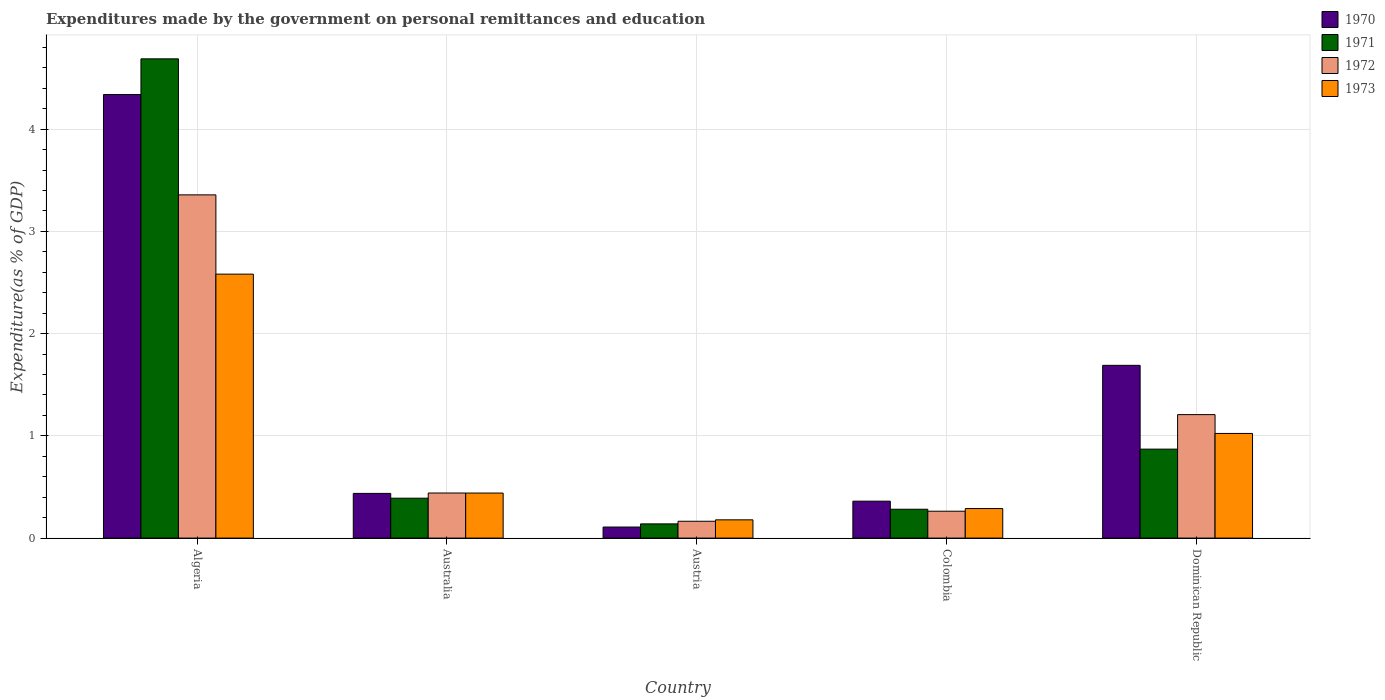How many groups of bars are there?
Provide a succinct answer. 5. Are the number of bars per tick equal to the number of legend labels?
Your response must be concise. Yes. Are the number of bars on each tick of the X-axis equal?
Provide a short and direct response. Yes. How many bars are there on the 3rd tick from the left?
Your answer should be very brief. 4. How many bars are there on the 3rd tick from the right?
Keep it short and to the point. 4. What is the label of the 1st group of bars from the left?
Your answer should be compact. Algeria. What is the expenditures made by the government on personal remittances and education in 1970 in Algeria?
Provide a succinct answer. 4.34. Across all countries, what is the maximum expenditures made by the government on personal remittances and education in 1970?
Offer a terse response. 4.34. Across all countries, what is the minimum expenditures made by the government on personal remittances and education in 1970?
Offer a terse response. 0.11. In which country was the expenditures made by the government on personal remittances and education in 1971 maximum?
Give a very brief answer. Algeria. What is the total expenditures made by the government on personal remittances and education in 1972 in the graph?
Keep it short and to the point. 5.43. What is the difference between the expenditures made by the government on personal remittances and education in 1973 in Algeria and that in Dominican Republic?
Make the answer very short. 1.56. What is the difference between the expenditures made by the government on personal remittances and education in 1970 in Algeria and the expenditures made by the government on personal remittances and education in 1971 in Australia?
Offer a terse response. 3.95. What is the average expenditures made by the government on personal remittances and education in 1971 per country?
Your response must be concise. 1.27. What is the difference between the expenditures made by the government on personal remittances and education of/in 1970 and expenditures made by the government on personal remittances and education of/in 1971 in Austria?
Provide a succinct answer. -0.03. What is the ratio of the expenditures made by the government on personal remittances and education in 1970 in Algeria to that in Austria?
Offer a terse response. 40.14. What is the difference between the highest and the second highest expenditures made by the government on personal remittances and education in 1970?
Provide a succinct answer. -1.25. What is the difference between the highest and the lowest expenditures made by the government on personal remittances and education in 1970?
Your response must be concise. 4.23. What does the 1st bar from the left in Australia represents?
Ensure brevity in your answer.  1970. How many bars are there?
Provide a succinct answer. 20. Are the values on the major ticks of Y-axis written in scientific E-notation?
Ensure brevity in your answer.  No. Does the graph contain grids?
Provide a short and direct response. Yes. How many legend labels are there?
Ensure brevity in your answer.  4. What is the title of the graph?
Offer a very short reply. Expenditures made by the government on personal remittances and education. Does "1961" appear as one of the legend labels in the graph?
Your response must be concise. No. What is the label or title of the Y-axis?
Provide a succinct answer. Expenditure(as % of GDP). What is the Expenditure(as % of GDP) in 1970 in Algeria?
Your response must be concise. 4.34. What is the Expenditure(as % of GDP) of 1971 in Algeria?
Offer a terse response. 4.69. What is the Expenditure(as % of GDP) of 1972 in Algeria?
Your answer should be very brief. 3.36. What is the Expenditure(as % of GDP) of 1973 in Algeria?
Your response must be concise. 2.58. What is the Expenditure(as % of GDP) in 1970 in Australia?
Your answer should be compact. 0.44. What is the Expenditure(as % of GDP) of 1971 in Australia?
Make the answer very short. 0.39. What is the Expenditure(as % of GDP) of 1972 in Australia?
Provide a short and direct response. 0.44. What is the Expenditure(as % of GDP) of 1973 in Australia?
Provide a short and direct response. 0.44. What is the Expenditure(as % of GDP) in 1970 in Austria?
Your answer should be compact. 0.11. What is the Expenditure(as % of GDP) of 1971 in Austria?
Your answer should be very brief. 0.14. What is the Expenditure(as % of GDP) of 1972 in Austria?
Offer a terse response. 0.16. What is the Expenditure(as % of GDP) of 1973 in Austria?
Your response must be concise. 0.18. What is the Expenditure(as % of GDP) of 1970 in Colombia?
Your answer should be very brief. 0.36. What is the Expenditure(as % of GDP) in 1971 in Colombia?
Offer a terse response. 0.28. What is the Expenditure(as % of GDP) in 1972 in Colombia?
Offer a very short reply. 0.26. What is the Expenditure(as % of GDP) of 1973 in Colombia?
Make the answer very short. 0.29. What is the Expenditure(as % of GDP) of 1970 in Dominican Republic?
Offer a very short reply. 1.69. What is the Expenditure(as % of GDP) of 1971 in Dominican Republic?
Your response must be concise. 0.87. What is the Expenditure(as % of GDP) in 1972 in Dominican Republic?
Provide a short and direct response. 1.21. What is the Expenditure(as % of GDP) in 1973 in Dominican Republic?
Your answer should be compact. 1.02. Across all countries, what is the maximum Expenditure(as % of GDP) of 1970?
Provide a short and direct response. 4.34. Across all countries, what is the maximum Expenditure(as % of GDP) in 1971?
Your answer should be compact. 4.69. Across all countries, what is the maximum Expenditure(as % of GDP) of 1972?
Your answer should be compact. 3.36. Across all countries, what is the maximum Expenditure(as % of GDP) of 1973?
Provide a succinct answer. 2.58. Across all countries, what is the minimum Expenditure(as % of GDP) of 1970?
Provide a short and direct response. 0.11. Across all countries, what is the minimum Expenditure(as % of GDP) of 1971?
Provide a short and direct response. 0.14. Across all countries, what is the minimum Expenditure(as % of GDP) in 1972?
Provide a succinct answer. 0.16. Across all countries, what is the minimum Expenditure(as % of GDP) in 1973?
Provide a succinct answer. 0.18. What is the total Expenditure(as % of GDP) in 1970 in the graph?
Keep it short and to the point. 6.93. What is the total Expenditure(as % of GDP) in 1971 in the graph?
Provide a succinct answer. 6.37. What is the total Expenditure(as % of GDP) of 1972 in the graph?
Give a very brief answer. 5.43. What is the total Expenditure(as % of GDP) in 1973 in the graph?
Your response must be concise. 4.51. What is the difference between the Expenditure(as % of GDP) of 1970 in Algeria and that in Australia?
Keep it short and to the point. 3.9. What is the difference between the Expenditure(as % of GDP) of 1971 in Algeria and that in Australia?
Ensure brevity in your answer.  4.3. What is the difference between the Expenditure(as % of GDP) in 1972 in Algeria and that in Australia?
Offer a terse response. 2.92. What is the difference between the Expenditure(as % of GDP) in 1973 in Algeria and that in Australia?
Provide a short and direct response. 2.14. What is the difference between the Expenditure(as % of GDP) of 1970 in Algeria and that in Austria?
Your response must be concise. 4.23. What is the difference between the Expenditure(as % of GDP) in 1971 in Algeria and that in Austria?
Provide a short and direct response. 4.55. What is the difference between the Expenditure(as % of GDP) of 1972 in Algeria and that in Austria?
Give a very brief answer. 3.19. What is the difference between the Expenditure(as % of GDP) in 1973 in Algeria and that in Austria?
Keep it short and to the point. 2.4. What is the difference between the Expenditure(as % of GDP) in 1970 in Algeria and that in Colombia?
Make the answer very short. 3.98. What is the difference between the Expenditure(as % of GDP) in 1971 in Algeria and that in Colombia?
Provide a succinct answer. 4.41. What is the difference between the Expenditure(as % of GDP) of 1972 in Algeria and that in Colombia?
Give a very brief answer. 3.09. What is the difference between the Expenditure(as % of GDP) in 1973 in Algeria and that in Colombia?
Keep it short and to the point. 2.29. What is the difference between the Expenditure(as % of GDP) of 1970 in Algeria and that in Dominican Republic?
Keep it short and to the point. 2.65. What is the difference between the Expenditure(as % of GDP) in 1971 in Algeria and that in Dominican Republic?
Offer a very short reply. 3.82. What is the difference between the Expenditure(as % of GDP) in 1972 in Algeria and that in Dominican Republic?
Your response must be concise. 2.15. What is the difference between the Expenditure(as % of GDP) in 1973 in Algeria and that in Dominican Republic?
Offer a terse response. 1.56. What is the difference between the Expenditure(as % of GDP) of 1970 in Australia and that in Austria?
Keep it short and to the point. 0.33. What is the difference between the Expenditure(as % of GDP) in 1971 in Australia and that in Austria?
Ensure brevity in your answer.  0.25. What is the difference between the Expenditure(as % of GDP) of 1972 in Australia and that in Austria?
Your answer should be very brief. 0.28. What is the difference between the Expenditure(as % of GDP) of 1973 in Australia and that in Austria?
Your answer should be compact. 0.26. What is the difference between the Expenditure(as % of GDP) in 1970 in Australia and that in Colombia?
Provide a short and direct response. 0.08. What is the difference between the Expenditure(as % of GDP) in 1971 in Australia and that in Colombia?
Ensure brevity in your answer.  0.11. What is the difference between the Expenditure(as % of GDP) in 1972 in Australia and that in Colombia?
Offer a very short reply. 0.18. What is the difference between the Expenditure(as % of GDP) of 1973 in Australia and that in Colombia?
Make the answer very short. 0.15. What is the difference between the Expenditure(as % of GDP) in 1970 in Australia and that in Dominican Republic?
Keep it short and to the point. -1.25. What is the difference between the Expenditure(as % of GDP) in 1971 in Australia and that in Dominican Republic?
Make the answer very short. -0.48. What is the difference between the Expenditure(as % of GDP) of 1972 in Australia and that in Dominican Republic?
Your answer should be compact. -0.77. What is the difference between the Expenditure(as % of GDP) in 1973 in Australia and that in Dominican Republic?
Provide a succinct answer. -0.58. What is the difference between the Expenditure(as % of GDP) of 1970 in Austria and that in Colombia?
Your response must be concise. -0.25. What is the difference between the Expenditure(as % of GDP) in 1971 in Austria and that in Colombia?
Your answer should be very brief. -0.14. What is the difference between the Expenditure(as % of GDP) in 1972 in Austria and that in Colombia?
Give a very brief answer. -0.1. What is the difference between the Expenditure(as % of GDP) of 1973 in Austria and that in Colombia?
Give a very brief answer. -0.11. What is the difference between the Expenditure(as % of GDP) of 1970 in Austria and that in Dominican Republic?
Keep it short and to the point. -1.58. What is the difference between the Expenditure(as % of GDP) of 1971 in Austria and that in Dominican Republic?
Provide a short and direct response. -0.73. What is the difference between the Expenditure(as % of GDP) of 1972 in Austria and that in Dominican Republic?
Your answer should be compact. -1.04. What is the difference between the Expenditure(as % of GDP) in 1973 in Austria and that in Dominican Republic?
Offer a very short reply. -0.84. What is the difference between the Expenditure(as % of GDP) in 1970 in Colombia and that in Dominican Republic?
Provide a succinct answer. -1.33. What is the difference between the Expenditure(as % of GDP) of 1971 in Colombia and that in Dominican Republic?
Give a very brief answer. -0.59. What is the difference between the Expenditure(as % of GDP) in 1972 in Colombia and that in Dominican Republic?
Provide a succinct answer. -0.94. What is the difference between the Expenditure(as % of GDP) in 1973 in Colombia and that in Dominican Republic?
Make the answer very short. -0.73. What is the difference between the Expenditure(as % of GDP) of 1970 in Algeria and the Expenditure(as % of GDP) of 1971 in Australia?
Keep it short and to the point. 3.95. What is the difference between the Expenditure(as % of GDP) of 1970 in Algeria and the Expenditure(as % of GDP) of 1972 in Australia?
Keep it short and to the point. 3.9. What is the difference between the Expenditure(as % of GDP) in 1970 in Algeria and the Expenditure(as % of GDP) in 1973 in Australia?
Provide a succinct answer. 3.9. What is the difference between the Expenditure(as % of GDP) of 1971 in Algeria and the Expenditure(as % of GDP) of 1972 in Australia?
Provide a short and direct response. 4.25. What is the difference between the Expenditure(as % of GDP) in 1971 in Algeria and the Expenditure(as % of GDP) in 1973 in Australia?
Offer a very short reply. 4.25. What is the difference between the Expenditure(as % of GDP) of 1972 in Algeria and the Expenditure(as % of GDP) of 1973 in Australia?
Your response must be concise. 2.92. What is the difference between the Expenditure(as % of GDP) of 1970 in Algeria and the Expenditure(as % of GDP) of 1971 in Austria?
Ensure brevity in your answer.  4.2. What is the difference between the Expenditure(as % of GDP) of 1970 in Algeria and the Expenditure(as % of GDP) of 1972 in Austria?
Offer a terse response. 4.17. What is the difference between the Expenditure(as % of GDP) in 1970 in Algeria and the Expenditure(as % of GDP) in 1973 in Austria?
Provide a succinct answer. 4.16. What is the difference between the Expenditure(as % of GDP) in 1971 in Algeria and the Expenditure(as % of GDP) in 1972 in Austria?
Provide a succinct answer. 4.52. What is the difference between the Expenditure(as % of GDP) of 1971 in Algeria and the Expenditure(as % of GDP) of 1973 in Austria?
Keep it short and to the point. 4.51. What is the difference between the Expenditure(as % of GDP) of 1972 in Algeria and the Expenditure(as % of GDP) of 1973 in Austria?
Offer a terse response. 3.18. What is the difference between the Expenditure(as % of GDP) in 1970 in Algeria and the Expenditure(as % of GDP) in 1971 in Colombia?
Provide a short and direct response. 4.06. What is the difference between the Expenditure(as % of GDP) of 1970 in Algeria and the Expenditure(as % of GDP) of 1972 in Colombia?
Offer a very short reply. 4.08. What is the difference between the Expenditure(as % of GDP) of 1970 in Algeria and the Expenditure(as % of GDP) of 1973 in Colombia?
Make the answer very short. 4.05. What is the difference between the Expenditure(as % of GDP) in 1971 in Algeria and the Expenditure(as % of GDP) in 1972 in Colombia?
Provide a short and direct response. 4.42. What is the difference between the Expenditure(as % of GDP) of 1971 in Algeria and the Expenditure(as % of GDP) of 1973 in Colombia?
Keep it short and to the point. 4.4. What is the difference between the Expenditure(as % of GDP) in 1972 in Algeria and the Expenditure(as % of GDP) in 1973 in Colombia?
Make the answer very short. 3.07. What is the difference between the Expenditure(as % of GDP) in 1970 in Algeria and the Expenditure(as % of GDP) in 1971 in Dominican Republic?
Your answer should be compact. 3.47. What is the difference between the Expenditure(as % of GDP) of 1970 in Algeria and the Expenditure(as % of GDP) of 1972 in Dominican Republic?
Provide a short and direct response. 3.13. What is the difference between the Expenditure(as % of GDP) of 1970 in Algeria and the Expenditure(as % of GDP) of 1973 in Dominican Republic?
Offer a very short reply. 3.31. What is the difference between the Expenditure(as % of GDP) in 1971 in Algeria and the Expenditure(as % of GDP) in 1972 in Dominican Republic?
Your answer should be very brief. 3.48. What is the difference between the Expenditure(as % of GDP) of 1971 in Algeria and the Expenditure(as % of GDP) of 1973 in Dominican Republic?
Your answer should be compact. 3.66. What is the difference between the Expenditure(as % of GDP) in 1972 in Algeria and the Expenditure(as % of GDP) in 1973 in Dominican Republic?
Give a very brief answer. 2.33. What is the difference between the Expenditure(as % of GDP) in 1970 in Australia and the Expenditure(as % of GDP) in 1971 in Austria?
Give a very brief answer. 0.3. What is the difference between the Expenditure(as % of GDP) of 1970 in Australia and the Expenditure(as % of GDP) of 1972 in Austria?
Offer a very short reply. 0.27. What is the difference between the Expenditure(as % of GDP) in 1970 in Australia and the Expenditure(as % of GDP) in 1973 in Austria?
Your answer should be compact. 0.26. What is the difference between the Expenditure(as % of GDP) in 1971 in Australia and the Expenditure(as % of GDP) in 1972 in Austria?
Make the answer very short. 0.23. What is the difference between the Expenditure(as % of GDP) in 1971 in Australia and the Expenditure(as % of GDP) in 1973 in Austria?
Give a very brief answer. 0.21. What is the difference between the Expenditure(as % of GDP) of 1972 in Australia and the Expenditure(as % of GDP) of 1973 in Austria?
Provide a succinct answer. 0.26. What is the difference between the Expenditure(as % of GDP) of 1970 in Australia and the Expenditure(as % of GDP) of 1971 in Colombia?
Make the answer very short. 0.15. What is the difference between the Expenditure(as % of GDP) in 1970 in Australia and the Expenditure(as % of GDP) in 1972 in Colombia?
Provide a succinct answer. 0.17. What is the difference between the Expenditure(as % of GDP) of 1970 in Australia and the Expenditure(as % of GDP) of 1973 in Colombia?
Provide a succinct answer. 0.15. What is the difference between the Expenditure(as % of GDP) of 1971 in Australia and the Expenditure(as % of GDP) of 1972 in Colombia?
Make the answer very short. 0.13. What is the difference between the Expenditure(as % of GDP) of 1971 in Australia and the Expenditure(as % of GDP) of 1973 in Colombia?
Your answer should be very brief. 0.1. What is the difference between the Expenditure(as % of GDP) of 1972 in Australia and the Expenditure(as % of GDP) of 1973 in Colombia?
Offer a terse response. 0.15. What is the difference between the Expenditure(as % of GDP) of 1970 in Australia and the Expenditure(as % of GDP) of 1971 in Dominican Republic?
Make the answer very short. -0.43. What is the difference between the Expenditure(as % of GDP) in 1970 in Australia and the Expenditure(as % of GDP) in 1972 in Dominican Republic?
Your answer should be very brief. -0.77. What is the difference between the Expenditure(as % of GDP) of 1970 in Australia and the Expenditure(as % of GDP) of 1973 in Dominican Republic?
Offer a terse response. -0.59. What is the difference between the Expenditure(as % of GDP) in 1971 in Australia and the Expenditure(as % of GDP) in 1972 in Dominican Republic?
Provide a succinct answer. -0.82. What is the difference between the Expenditure(as % of GDP) in 1971 in Australia and the Expenditure(as % of GDP) in 1973 in Dominican Republic?
Keep it short and to the point. -0.63. What is the difference between the Expenditure(as % of GDP) of 1972 in Australia and the Expenditure(as % of GDP) of 1973 in Dominican Republic?
Offer a very short reply. -0.58. What is the difference between the Expenditure(as % of GDP) in 1970 in Austria and the Expenditure(as % of GDP) in 1971 in Colombia?
Give a very brief answer. -0.17. What is the difference between the Expenditure(as % of GDP) in 1970 in Austria and the Expenditure(as % of GDP) in 1972 in Colombia?
Your answer should be very brief. -0.15. What is the difference between the Expenditure(as % of GDP) in 1970 in Austria and the Expenditure(as % of GDP) in 1973 in Colombia?
Your response must be concise. -0.18. What is the difference between the Expenditure(as % of GDP) of 1971 in Austria and the Expenditure(as % of GDP) of 1972 in Colombia?
Offer a terse response. -0.12. What is the difference between the Expenditure(as % of GDP) of 1971 in Austria and the Expenditure(as % of GDP) of 1973 in Colombia?
Offer a very short reply. -0.15. What is the difference between the Expenditure(as % of GDP) of 1972 in Austria and the Expenditure(as % of GDP) of 1973 in Colombia?
Provide a succinct answer. -0.12. What is the difference between the Expenditure(as % of GDP) of 1970 in Austria and the Expenditure(as % of GDP) of 1971 in Dominican Republic?
Give a very brief answer. -0.76. What is the difference between the Expenditure(as % of GDP) of 1970 in Austria and the Expenditure(as % of GDP) of 1972 in Dominican Republic?
Ensure brevity in your answer.  -1.1. What is the difference between the Expenditure(as % of GDP) in 1970 in Austria and the Expenditure(as % of GDP) in 1973 in Dominican Republic?
Offer a very short reply. -0.92. What is the difference between the Expenditure(as % of GDP) of 1971 in Austria and the Expenditure(as % of GDP) of 1972 in Dominican Republic?
Give a very brief answer. -1.07. What is the difference between the Expenditure(as % of GDP) in 1971 in Austria and the Expenditure(as % of GDP) in 1973 in Dominican Republic?
Provide a succinct answer. -0.88. What is the difference between the Expenditure(as % of GDP) of 1972 in Austria and the Expenditure(as % of GDP) of 1973 in Dominican Republic?
Offer a very short reply. -0.86. What is the difference between the Expenditure(as % of GDP) in 1970 in Colombia and the Expenditure(as % of GDP) in 1971 in Dominican Republic?
Your response must be concise. -0.51. What is the difference between the Expenditure(as % of GDP) of 1970 in Colombia and the Expenditure(as % of GDP) of 1972 in Dominican Republic?
Your answer should be compact. -0.85. What is the difference between the Expenditure(as % of GDP) in 1970 in Colombia and the Expenditure(as % of GDP) in 1973 in Dominican Republic?
Provide a succinct answer. -0.66. What is the difference between the Expenditure(as % of GDP) in 1971 in Colombia and the Expenditure(as % of GDP) in 1972 in Dominican Republic?
Offer a terse response. -0.93. What is the difference between the Expenditure(as % of GDP) of 1971 in Colombia and the Expenditure(as % of GDP) of 1973 in Dominican Republic?
Give a very brief answer. -0.74. What is the difference between the Expenditure(as % of GDP) in 1972 in Colombia and the Expenditure(as % of GDP) in 1973 in Dominican Republic?
Offer a terse response. -0.76. What is the average Expenditure(as % of GDP) in 1970 per country?
Offer a terse response. 1.39. What is the average Expenditure(as % of GDP) of 1971 per country?
Offer a terse response. 1.27. What is the average Expenditure(as % of GDP) of 1972 per country?
Your answer should be very brief. 1.09. What is the average Expenditure(as % of GDP) in 1973 per country?
Keep it short and to the point. 0.9. What is the difference between the Expenditure(as % of GDP) of 1970 and Expenditure(as % of GDP) of 1971 in Algeria?
Ensure brevity in your answer.  -0.35. What is the difference between the Expenditure(as % of GDP) in 1970 and Expenditure(as % of GDP) in 1972 in Algeria?
Provide a succinct answer. 0.98. What is the difference between the Expenditure(as % of GDP) in 1970 and Expenditure(as % of GDP) in 1973 in Algeria?
Give a very brief answer. 1.76. What is the difference between the Expenditure(as % of GDP) of 1971 and Expenditure(as % of GDP) of 1972 in Algeria?
Your answer should be compact. 1.33. What is the difference between the Expenditure(as % of GDP) in 1971 and Expenditure(as % of GDP) in 1973 in Algeria?
Ensure brevity in your answer.  2.11. What is the difference between the Expenditure(as % of GDP) of 1972 and Expenditure(as % of GDP) of 1973 in Algeria?
Ensure brevity in your answer.  0.78. What is the difference between the Expenditure(as % of GDP) of 1970 and Expenditure(as % of GDP) of 1971 in Australia?
Your answer should be compact. 0.05. What is the difference between the Expenditure(as % of GDP) of 1970 and Expenditure(as % of GDP) of 1972 in Australia?
Offer a terse response. -0. What is the difference between the Expenditure(as % of GDP) of 1970 and Expenditure(as % of GDP) of 1973 in Australia?
Offer a terse response. -0. What is the difference between the Expenditure(as % of GDP) in 1971 and Expenditure(as % of GDP) in 1972 in Australia?
Your answer should be very brief. -0.05. What is the difference between the Expenditure(as % of GDP) of 1971 and Expenditure(as % of GDP) of 1973 in Australia?
Keep it short and to the point. -0.05. What is the difference between the Expenditure(as % of GDP) in 1970 and Expenditure(as % of GDP) in 1971 in Austria?
Make the answer very short. -0.03. What is the difference between the Expenditure(as % of GDP) of 1970 and Expenditure(as % of GDP) of 1972 in Austria?
Provide a short and direct response. -0.06. What is the difference between the Expenditure(as % of GDP) in 1970 and Expenditure(as % of GDP) in 1973 in Austria?
Your answer should be compact. -0.07. What is the difference between the Expenditure(as % of GDP) in 1971 and Expenditure(as % of GDP) in 1972 in Austria?
Your response must be concise. -0.03. What is the difference between the Expenditure(as % of GDP) in 1971 and Expenditure(as % of GDP) in 1973 in Austria?
Offer a terse response. -0.04. What is the difference between the Expenditure(as % of GDP) of 1972 and Expenditure(as % of GDP) of 1973 in Austria?
Ensure brevity in your answer.  -0.01. What is the difference between the Expenditure(as % of GDP) in 1970 and Expenditure(as % of GDP) in 1971 in Colombia?
Offer a very short reply. 0.08. What is the difference between the Expenditure(as % of GDP) in 1970 and Expenditure(as % of GDP) in 1972 in Colombia?
Provide a short and direct response. 0.1. What is the difference between the Expenditure(as % of GDP) in 1970 and Expenditure(as % of GDP) in 1973 in Colombia?
Your answer should be compact. 0.07. What is the difference between the Expenditure(as % of GDP) in 1971 and Expenditure(as % of GDP) in 1972 in Colombia?
Offer a very short reply. 0.02. What is the difference between the Expenditure(as % of GDP) in 1971 and Expenditure(as % of GDP) in 1973 in Colombia?
Your response must be concise. -0.01. What is the difference between the Expenditure(as % of GDP) in 1972 and Expenditure(as % of GDP) in 1973 in Colombia?
Offer a terse response. -0.03. What is the difference between the Expenditure(as % of GDP) of 1970 and Expenditure(as % of GDP) of 1971 in Dominican Republic?
Offer a very short reply. 0.82. What is the difference between the Expenditure(as % of GDP) in 1970 and Expenditure(as % of GDP) in 1972 in Dominican Republic?
Your answer should be compact. 0.48. What is the difference between the Expenditure(as % of GDP) of 1970 and Expenditure(as % of GDP) of 1973 in Dominican Republic?
Give a very brief answer. 0.67. What is the difference between the Expenditure(as % of GDP) in 1971 and Expenditure(as % of GDP) in 1972 in Dominican Republic?
Your response must be concise. -0.34. What is the difference between the Expenditure(as % of GDP) of 1971 and Expenditure(as % of GDP) of 1973 in Dominican Republic?
Provide a succinct answer. -0.15. What is the difference between the Expenditure(as % of GDP) of 1972 and Expenditure(as % of GDP) of 1973 in Dominican Republic?
Offer a very short reply. 0.18. What is the ratio of the Expenditure(as % of GDP) in 1970 in Algeria to that in Australia?
Your answer should be compact. 9.92. What is the ratio of the Expenditure(as % of GDP) of 1971 in Algeria to that in Australia?
Provide a succinct answer. 12.01. What is the ratio of the Expenditure(as % of GDP) of 1972 in Algeria to that in Australia?
Offer a very short reply. 7.61. What is the ratio of the Expenditure(as % of GDP) of 1973 in Algeria to that in Australia?
Keep it short and to the point. 5.86. What is the ratio of the Expenditure(as % of GDP) in 1970 in Algeria to that in Austria?
Your response must be concise. 40.14. What is the ratio of the Expenditure(as % of GDP) in 1971 in Algeria to that in Austria?
Ensure brevity in your answer.  33.73. What is the ratio of the Expenditure(as % of GDP) of 1972 in Algeria to that in Austria?
Provide a succinct answer. 20.38. What is the ratio of the Expenditure(as % of GDP) in 1973 in Algeria to that in Austria?
Give a very brief answer. 14.45. What is the ratio of the Expenditure(as % of GDP) in 1970 in Algeria to that in Colombia?
Your answer should be very brief. 12.01. What is the ratio of the Expenditure(as % of GDP) of 1971 in Algeria to that in Colombia?
Make the answer very short. 16.61. What is the ratio of the Expenditure(as % of GDP) of 1972 in Algeria to that in Colombia?
Keep it short and to the point. 12.77. What is the ratio of the Expenditure(as % of GDP) in 1973 in Algeria to that in Colombia?
Your answer should be compact. 8.94. What is the ratio of the Expenditure(as % of GDP) in 1970 in Algeria to that in Dominican Republic?
Ensure brevity in your answer.  2.57. What is the ratio of the Expenditure(as % of GDP) of 1971 in Algeria to that in Dominican Republic?
Provide a short and direct response. 5.39. What is the ratio of the Expenditure(as % of GDP) of 1972 in Algeria to that in Dominican Republic?
Make the answer very short. 2.78. What is the ratio of the Expenditure(as % of GDP) of 1973 in Algeria to that in Dominican Republic?
Your answer should be compact. 2.52. What is the ratio of the Expenditure(as % of GDP) of 1970 in Australia to that in Austria?
Offer a very short reply. 4.04. What is the ratio of the Expenditure(as % of GDP) of 1971 in Australia to that in Austria?
Provide a short and direct response. 2.81. What is the ratio of the Expenditure(as % of GDP) of 1972 in Australia to that in Austria?
Provide a short and direct response. 2.68. What is the ratio of the Expenditure(as % of GDP) in 1973 in Australia to that in Austria?
Provide a succinct answer. 2.47. What is the ratio of the Expenditure(as % of GDP) of 1970 in Australia to that in Colombia?
Your answer should be compact. 1.21. What is the ratio of the Expenditure(as % of GDP) of 1971 in Australia to that in Colombia?
Your response must be concise. 1.38. What is the ratio of the Expenditure(as % of GDP) in 1972 in Australia to that in Colombia?
Your answer should be compact. 1.68. What is the ratio of the Expenditure(as % of GDP) of 1973 in Australia to that in Colombia?
Your answer should be very brief. 1.52. What is the ratio of the Expenditure(as % of GDP) of 1970 in Australia to that in Dominican Republic?
Ensure brevity in your answer.  0.26. What is the ratio of the Expenditure(as % of GDP) of 1971 in Australia to that in Dominican Republic?
Ensure brevity in your answer.  0.45. What is the ratio of the Expenditure(as % of GDP) of 1972 in Australia to that in Dominican Republic?
Provide a succinct answer. 0.37. What is the ratio of the Expenditure(as % of GDP) in 1973 in Australia to that in Dominican Republic?
Offer a very short reply. 0.43. What is the ratio of the Expenditure(as % of GDP) in 1970 in Austria to that in Colombia?
Provide a short and direct response. 0.3. What is the ratio of the Expenditure(as % of GDP) in 1971 in Austria to that in Colombia?
Your answer should be compact. 0.49. What is the ratio of the Expenditure(as % of GDP) of 1972 in Austria to that in Colombia?
Provide a succinct answer. 0.63. What is the ratio of the Expenditure(as % of GDP) in 1973 in Austria to that in Colombia?
Make the answer very short. 0.62. What is the ratio of the Expenditure(as % of GDP) in 1970 in Austria to that in Dominican Republic?
Offer a terse response. 0.06. What is the ratio of the Expenditure(as % of GDP) of 1971 in Austria to that in Dominican Republic?
Offer a very short reply. 0.16. What is the ratio of the Expenditure(as % of GDP) in 1972 in Austria to that in Dominican Republic?
Your answer should be very brief. 0.14. What is the ratio of the Expenditure(as % of GDP) of 1973 in Austria to that in Dominican Republic?
Offer a very short reply. 0.17. What is the ratio of the Expenditure(as % of GDP) in 1970 in Colombia to that in Dominican Republic?
Give a very brief answer. 0.21. What is the ratio of the Expenditure(as % of GDP) of 1971 in Colombia to that in Dominican Republic?
Your answer should be very brief. 0.32. What is the ratio of the Expenditure(as % of GDP) in 1972 in Colombia to that in Dominican Republic?
Provide a short and direct response. 0.22. What is the ratio of the Expenditure(as % of GDP) in 1973 in Colombia to that in Dominican Republic?
Your response must be concise. 0.28. What is the difference between the highest and the second highest Expenditure(as % of GDP) in 1970?
Provide a short and direct response. 2.65. What is the difference between the highest and the second highest Expenditure(as % of GDP) of 1971?
Provide a short and direct response. 3.82. What is the difference between the highest and the second highest Expenditure(as % of GDP) of 1972?
Keep it short and to the point. 2.15. What is the difference between the highest and the second highest Expenditure(as % of GDP) in 1973?
Make the answer very short. 1.56. What is the difference between the highest and the lowest Expenditure(as % of GDP) of 1970?
Your answer should be compact. 4.23. What is the difference between the highest and the lowest Expenditure(as % of GDP) in 1971?
Ensure brevity in your answer.  4.55. What is the difference between the highest and the lowest Expenditure(as % of GDP) of 1972?
Provide a short and direct response. 3.19. What is the difference between the highest and the lowest Expenditure(as % of GDP) in 1973?
Your response must be concise. 2.4. 